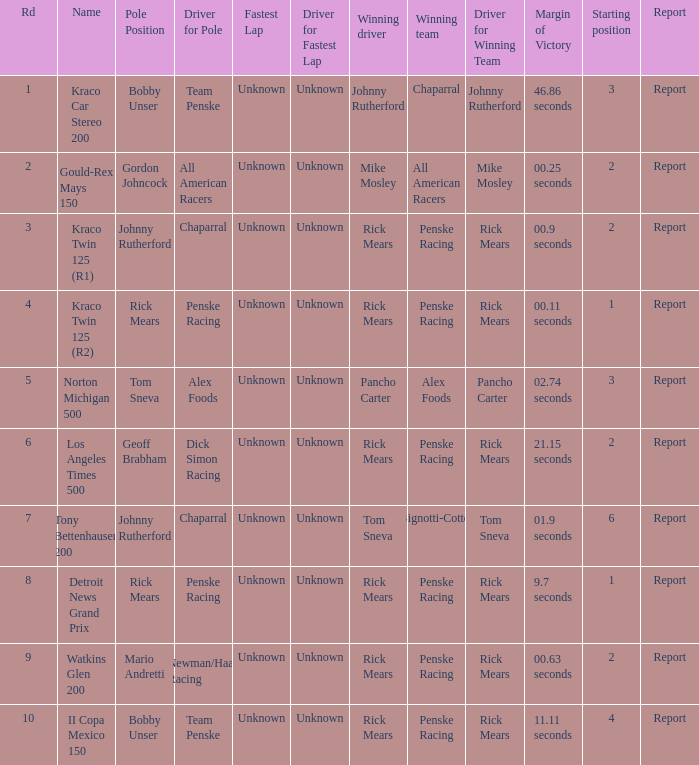The race tony bettenhausen 200 has what smallest rd? 7.0. 